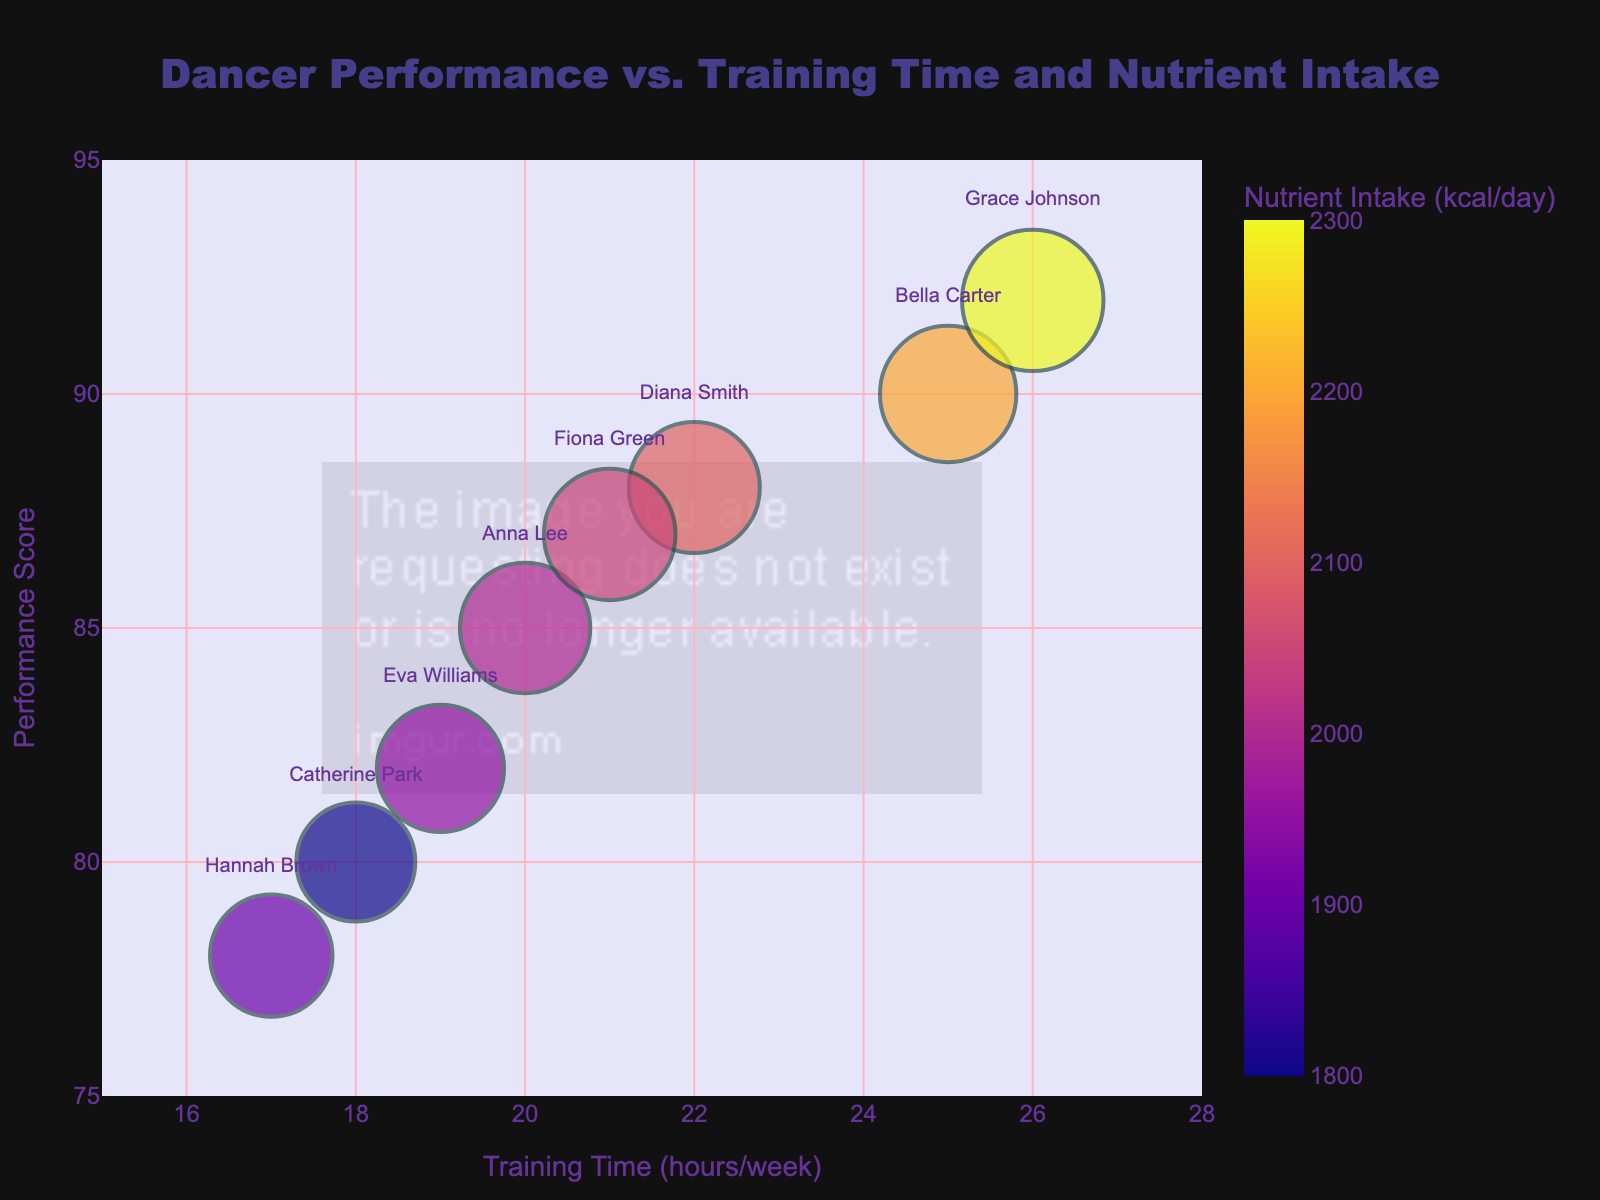What is the title of the chart? The title is displayed prominently at the top of the chart. It is the most straightforward piece of information to identify.
Answer: Dancer Performance vs. Training Time and Nutrient Intake How many dancers are represented in the chart? Each bubble in the chart represents a dancer, and by counting the bubbles, one can determine the total number of dancers.
Answer: 8 Which dancer has the highest Performance Score? By looking at the y-axis, which represents the Performance Score, and identifying the highest positioned bubble, you can determine the dancer with the highest score.
Answer: Grace Johnson Which dancer has the lowest Training Time? The x-axis represents Training Time. By identifying the bubble closest to the left end of the x-axis, you find the dancer with the lowest Training Time.
Answer: Hannah Brown What is the range of Performance Scores on the y-axis? The y-axis runs from a minimum value to a maximum value, which represents the range of Performance Scores.
Answer: 75 to 95 Does higher Training Time correlate with a higher Performance Score among the dancers? By observing the general trend of the bubbles from left to right on the x-axis and noting their positions on the y-axis, one can infer if there is a positive correlation. Most bubbles with higher Training Times are positioned higher on the y-axis, indicating a positive correlation.
Answer: Yes Which dancer has the largest bubble, and what does it represent? Bubbles' sizes represent Total Intake. The largest bubble belongs to the dancer with the highest Total Intake. By identifying the largest bubble, you can determine the corresponding dancer.
Answer: Grace Johnson What is the primary color representing the dancer with the highest Nutrient Intake (kcal/day)? The legend indicates colors correlated with Nutrient Intake (kcal/day). By identifying the bubble with the highest Nutrient Intake and checking its color, you can answer this question.
Answer: Dark orange Compare the Training Time and Performance Score of Anna Lee and Bella Carter. By locating the bubbles for Anna Lee and Bella Carter and referring to the x-axis for Training Time and y-axis for Performance Score, one can compare these values directly. Anna Lee has a Training Time of 20 hours/week and Performance Score of 85, while Bella Carter has 25 hours/week and a score of 90.
Answer: Anna Lee: 20 hours/week, 85; Bella Carter: 25 hours/week, 90 What is the total of Protein Intake (g/day) for all the dancers combined? Add up the Protein Intake values for each dancer to get the total. The combined Protein Intake is 100 + 120 + 90 + 110 + 105 + 115 + 130 + 95 = 865.
Answer: 865 